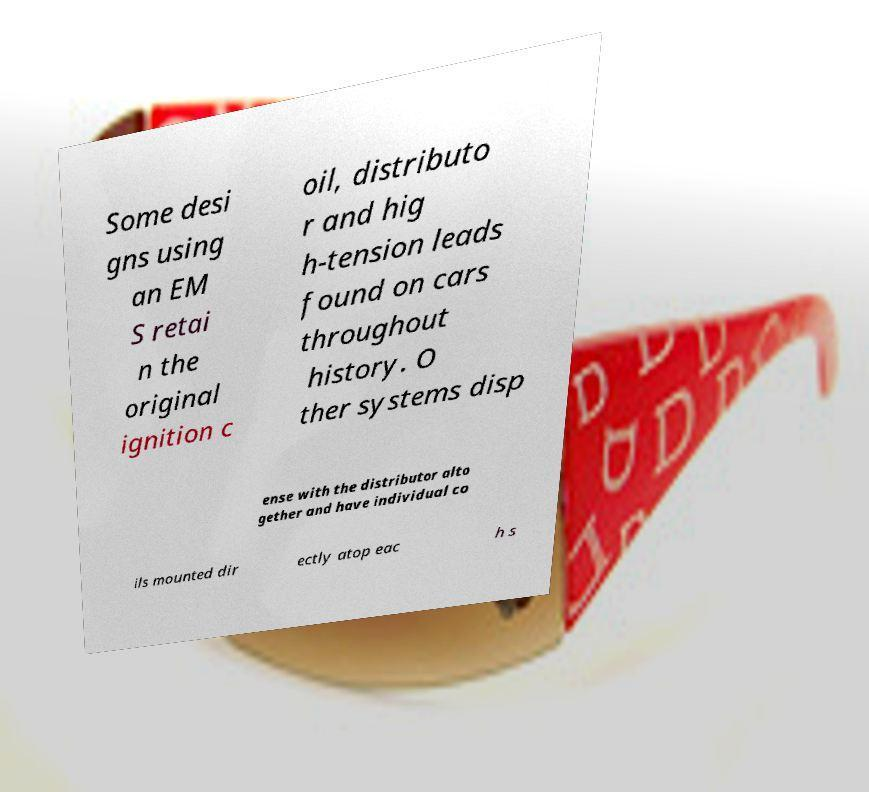Could you extract and type out the text from this image? Some desi gns using an EM S retai n the original ignition c oil, distributo r and hig h-tension leads found on cars throughout history. O ther systems disp ense with the distributor alto gether and have individual co ils mounted dir ectly atop eac h s 